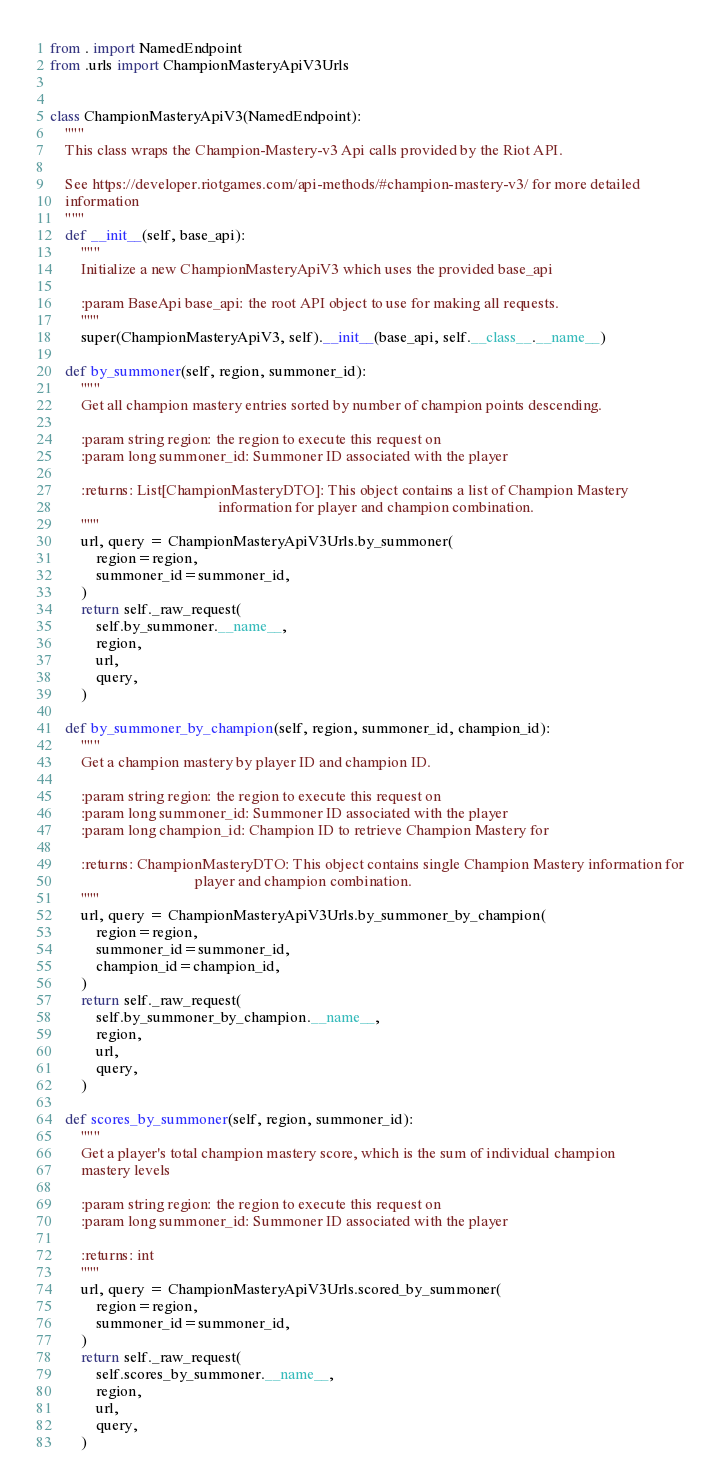Convert code to text. <code><loc_0><loc_0><loc_500><loc_500><_Python_>
from . import NamedEndpoint
from .urls import ChampionMasteryApiV3Urls


class ChampionMasteryApiV3(NamedEndpoint):
    """
    This class wraps the Champion-Mastery-v3 Api calls provided by the Riot API.

    See https://developer.riotgames.com/api-methods/#champion-mastery-v3/ for more detailed
    information
    """
    def __init__(self, base_api):
        """
        Initialize a new ChampionMasteryApiV3 which uses the provided base_api

        :param BaseApi base_api: the root API object to use for making all requests.
        """
        super(ChampionMasteryApiV3, self).__init__(base_api, self.__class__.__name__)

    def by_summoner(self, region, summoner_id):
        """
        Get all champion mastery entries sorted by number of champion points descending.

        :param string region: the region to execute this request on
        :param long summoner_id: Summoner ID associated with the player

        :returns: List[ChampionMasteryDTO]: This object contains a list of Champion Mastery
                                            information for player and champion combination.
        """
        url, query = ChampionMasteryApiV3Urls.by_summoner(
            region=region,
            summoner_id=summoner_id,
        )
        return self._raw_request(
            self.by_summoner.__name__,
            region,
            url,
            query,
        )

    def by_summoner_by_champion(self, region, summoner_id, champion_id):
        """
        Get a champion mastery by player ID and champion ID.

        :param string region: the region to execute this request on
        :param long summoner_id: Summoner ID associated with the player
        :param long champion_id: Champion ID to retrieve Champion Mastery for

        :returns: ChampionMasteryDTO: This object contains single Champion Mastery information for
                                      player and champion combination.
        """
        url, query = ChampionMasteryApiV3Urls.by_summoner_by_champion(
            region=region,
            summoner_id=summoner_id,
            champion_id=champion_id,
        )
        return self._raw_request(
            self.by_summoner_by_champion.__name__,
            region,
            url,
            query,
        )

    def scores_by_summoner(self, region, summoner_id):
        """
        Get a player's total champion mastery score, which is the sum of individual champion
        mastery levels

        :param string region: the region to execute this request on
        :param long summoner_id: Summoner ID associated with the player

        :returns: int
        """
        url, query = ChampionMasteryApiV3Urls.scored_by_summoner(
            region=region,
            summoner_id=summoner_id,
        )
        return self._raw_request(
            self.scores_by_summoner.__name__,
            region,
            url,
            query,
        )
</code> 